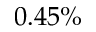<formula> <loc_0><loc_0><loc_500><loc_500>0 . 4 5 \%</formula> 